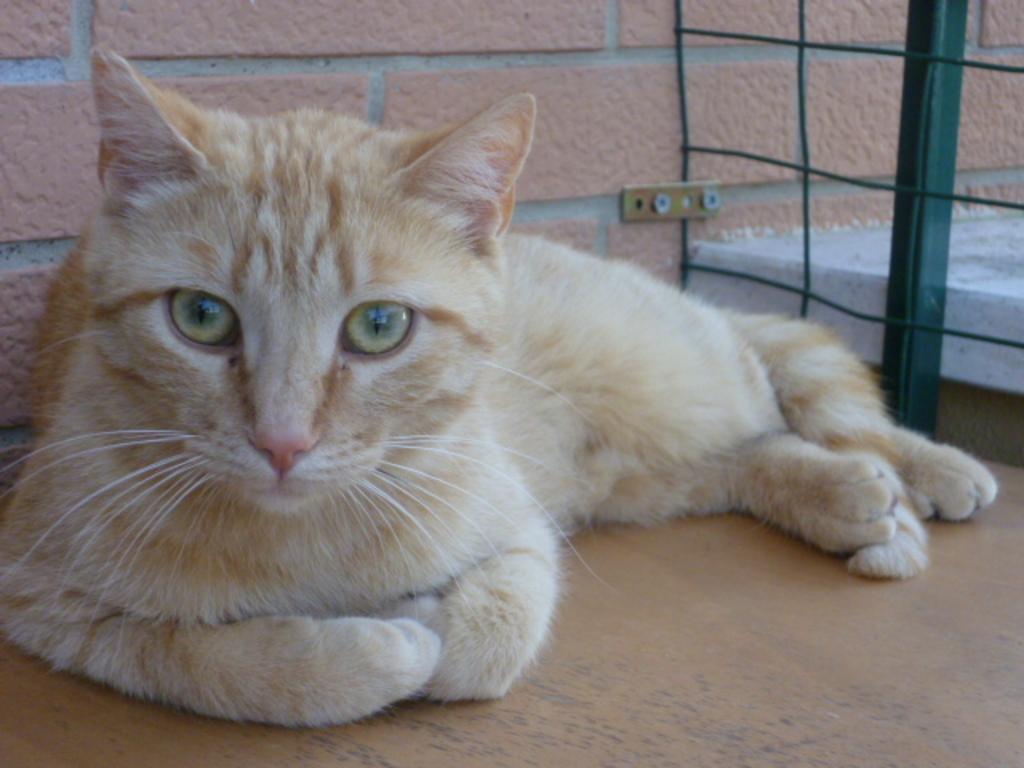In one or two sentences, can you explain what this image depicts? In this image I can see the cat which is in cream and brown color. To the right I can see the green color object looks like net fence. In the background I can see the wall. 